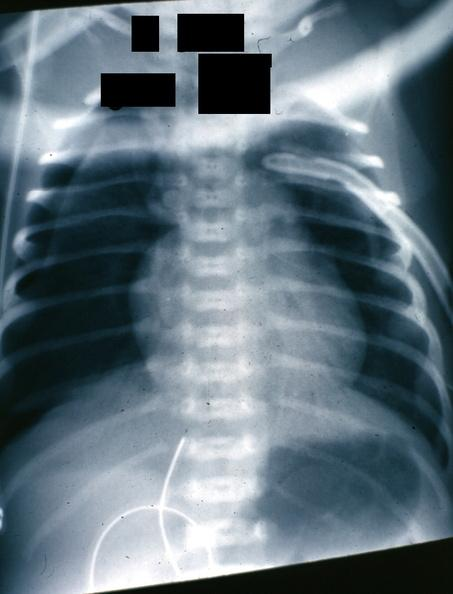what is present?
Answer the question using a single word or phrase. Lung 